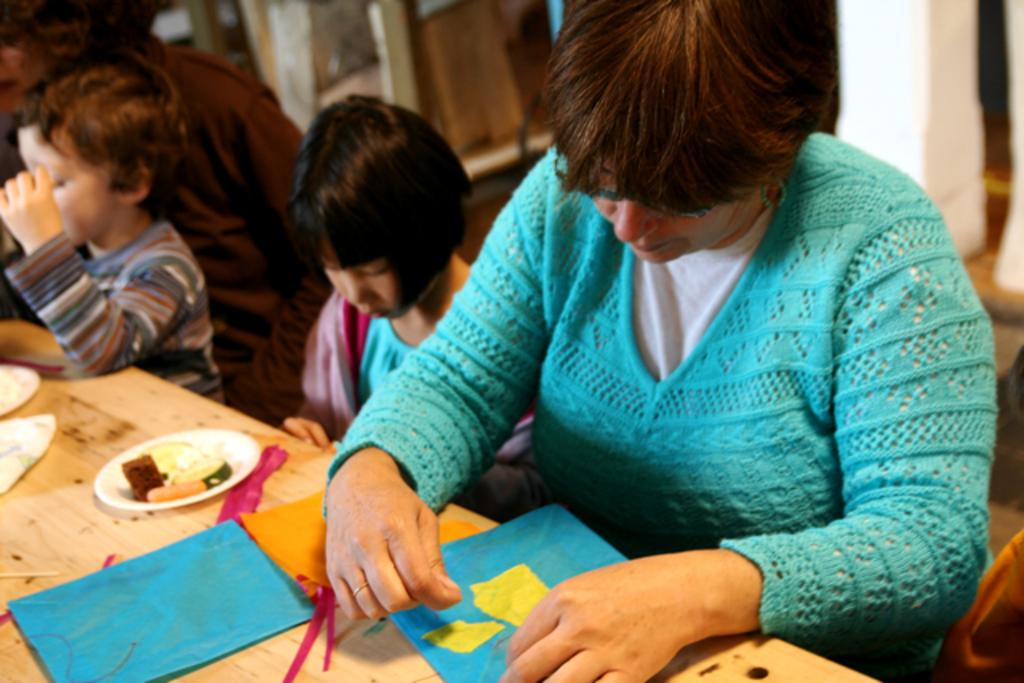How many people are sitting in the image? There are three people sitting in the image. What is the boy in the image doing? The boy is standing in the image. What is on the table in the image? There is a table in the image with papers, a plate of food, and some unspecified things on it. Where is the maid in the image? There is no maid present in the image. What type of net is being used by the people in the image? There is no net present in the image. 